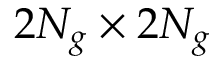<formula> <loc_0><loc_0><loc_500><loc_500>2 N _ { g } \times 2 N _ { g }</formula> 